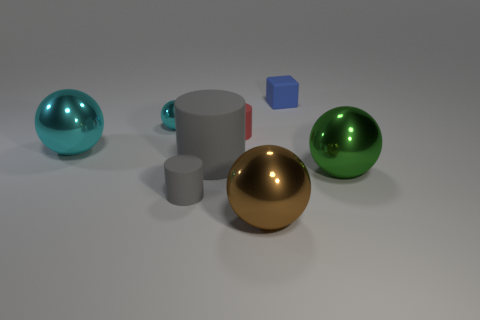How many cyan spheres must be subtracted to get 1 cyan spheres? 1 Subtract 1 balls. How many balls are left? 3 Add 1 gray cylinders. How many objects exist? 9 Subtract all blocks. How many objects are left? 7 Add 5 small cylinders. How many small cylinders are left? 7 Add 7 tiny brown metal cylinders. How many tiny brown metal cylinders exist? 7 Subtract 1 red cylinders. How many objects are left? 7 Subtract all large yellow matte objects. Subtract all large metal balls. How many objects are left? 5 